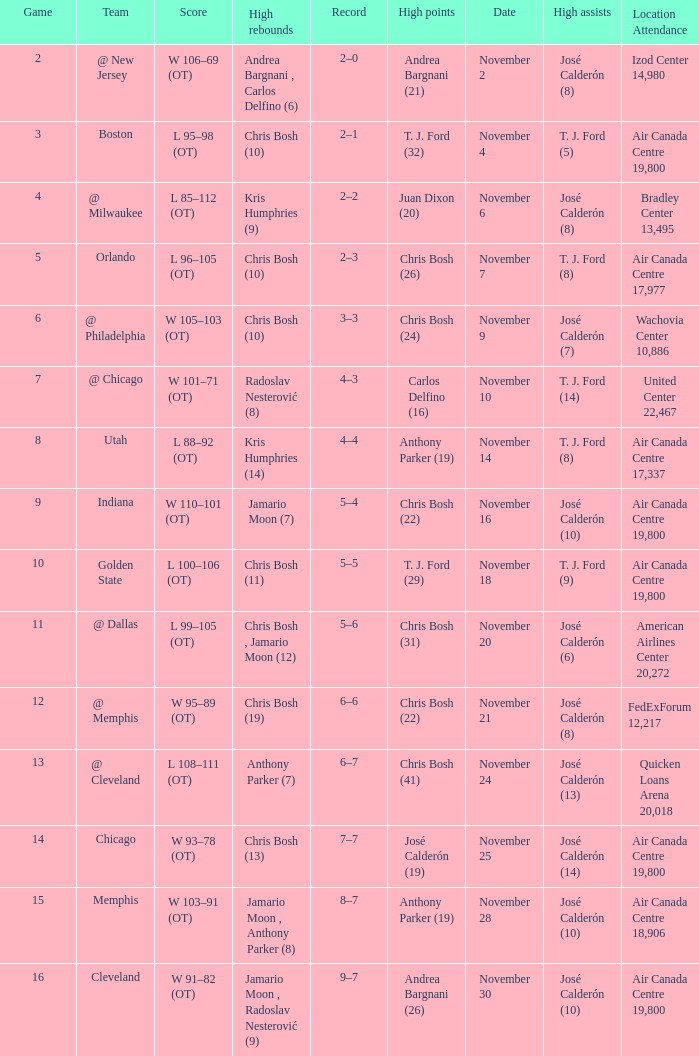Who had the high points when chris bosh (13) had the high rebounds? José Calderón (19). 